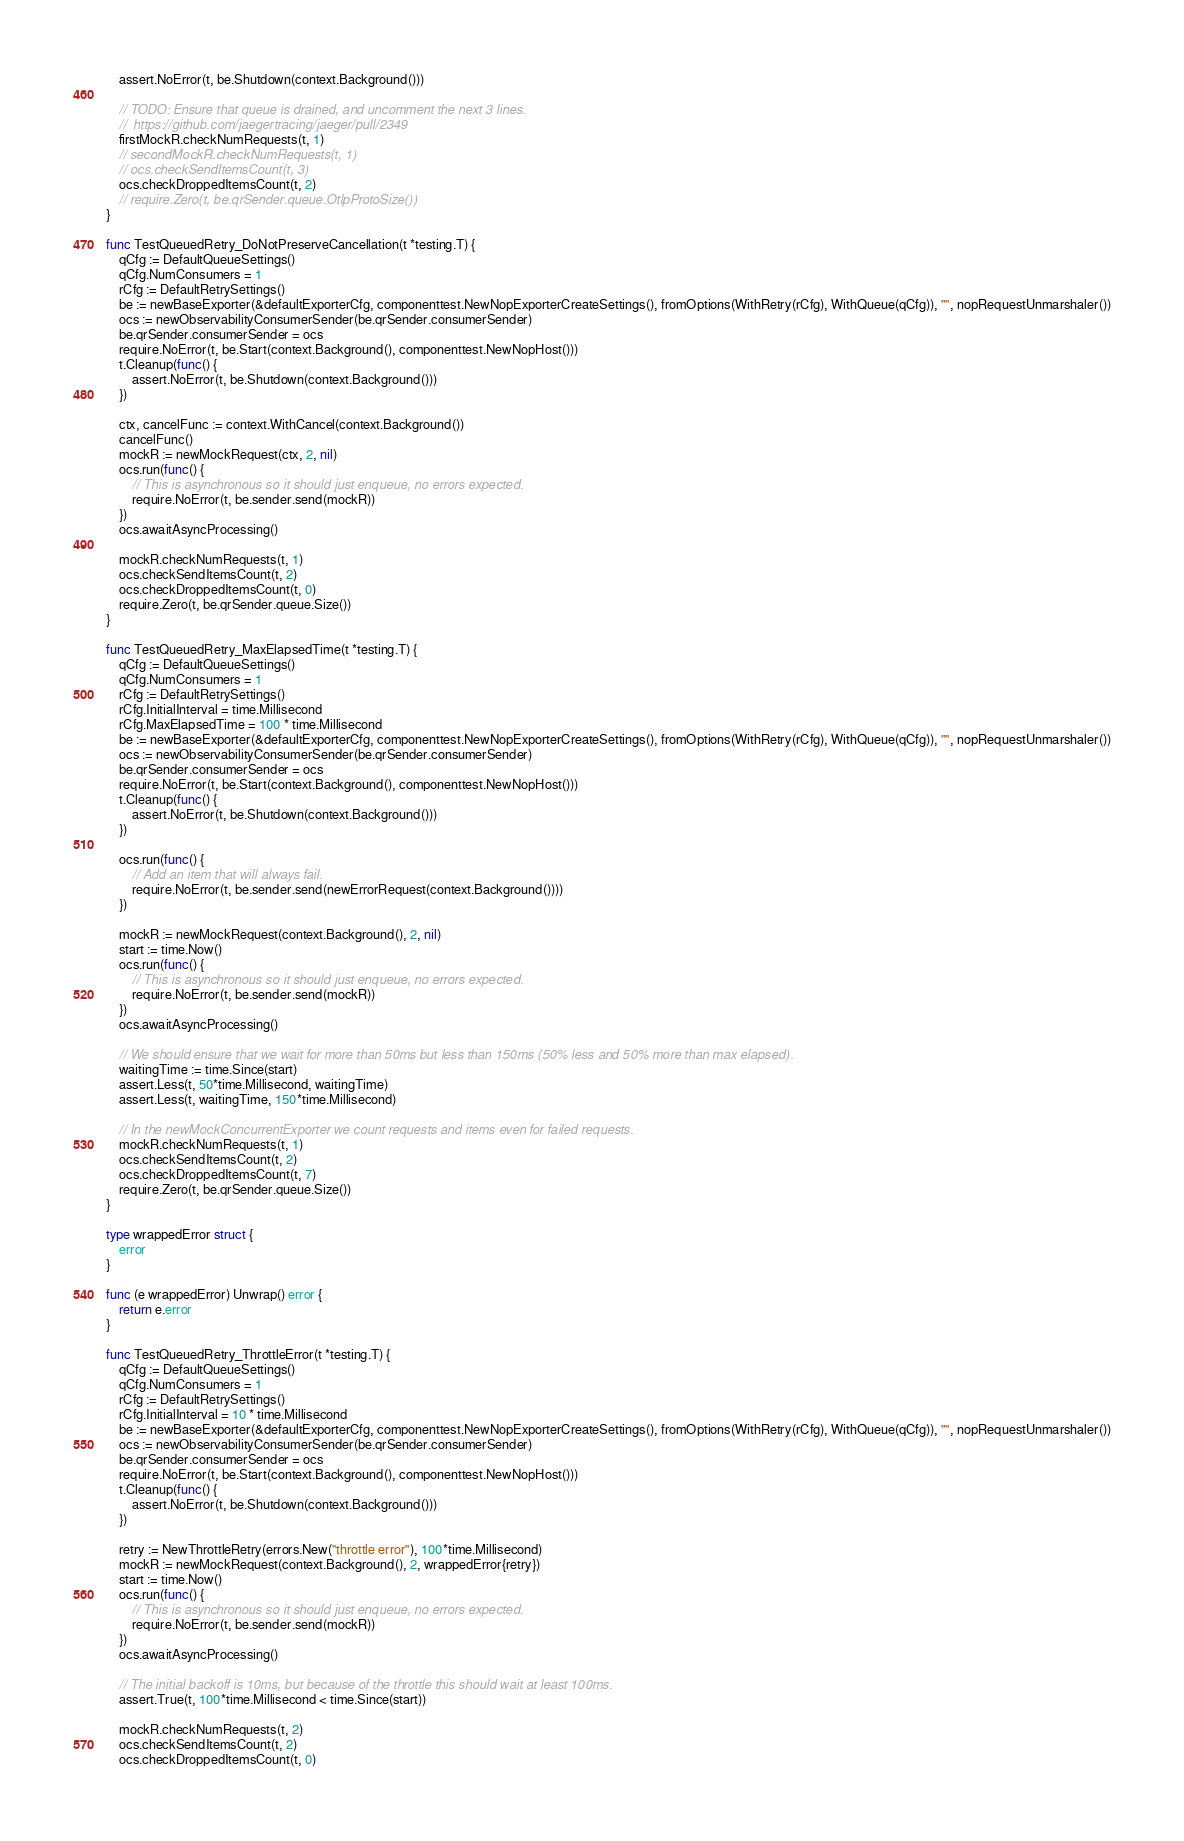Convert code to text. <code><loc_0><loc_0><loc_500><loc_500><_Go_>	assert.NoError(t, be.Shutdown(context.Background()))

	// TODO: Ensure that queue is drained, and uncomment the next 3 lines.
	//  https://github.com/jaegertracing/jaeger/pull/2349
	firstMockR.checkNumRequests(t, 1)
	// secondMockR.checkNumRequests(t, 1)
	// ocs.checkSendItemsCount(t, 3)
	ocs.checkDroppedItemsCount(t, 2)
	// require.Zero(t, be.qrSender.queue.OtlpProtoSize())
}

func TestQueuedRetry_DoNotPreserveCancellation(t *testing.T) {
	qCfg := DefaultQueueSettings()
	qCfg.NumConsumers = 1
	rCfg := DefaultRetrySettings()
	be := newBaseExporter(&defaultExporterCfg, componenttest.NewNopExporterCreateSettings(), fromOptions(WithRetry(rCfg), WithQueue(qCfg)), "", nopRequestUnmarshaler())
	ocs := newObservabilityConsumerSender(be.qrSender.consumerSender)
	be.qrSender.consumerSender = ocs
	require.NoError(t, be.Start(context.Background(), componenttest.NewNopHost()))
	t.Cleanup(func() {
		assert.NoError(t, be.Shutdown(context.Background()))
	})

	ctx, cancelFunc := context.WithCancel(context.Background())
	cancelFunc()
	mockR := newMockRequest(ctx, 2, nil)
	ocs.run(func() {
		// This is asynchronous so it should just enqueue, no errors expected.
		require.NoError(t, be.sender.send(mockR))
	})
	ocs.awaitAsyncProcessing()

	mockR.checkNumRequests(t, 1)
	ocs.checkSendItemsCount(t, 2)
	ocs.checkDroppedItemsCount(t, 0)
	require.Zero(t, be.qrSender.queue.Size())
}

func TestQueuedRetry_MaxElapsedTime(t *testing.T) {
	qCfg := DefaultQueueSettings()
	qCfg.NumConsumers = 1
	rCfg := DefaultRetrySettings()
	rCfg.InitialInterval = time.Millisecond
	rCfg.MaxElapsedTime = 100 * time.Millisecond
	be := newBaseExporter(&defaultExporterCfg, componenttest.NewNopExporterCreateSettings(), fromOptions(WithRetry(rCfg), WithQueue(qCfg)), "", nopRequestUnmarshaler())
	ocs := newObservabilityConsumerSender(be.qrSender.consumerSender)
	be.qrSender.consumerSender = ocs
	require.NoError(t, be.Start(context.Background(), componenttest.NewNopHost()))
	t.Cleanup(func() {
		assert.NoError(t, be.Shutdown(context.Background()))
	})

	ocs.run(func() {
		// Add an item that will always fail.
		require.NoError(t, be.sender.send(newErrorRequest(context.Background())))
	})

	mockR := newMockRequest(context.Background(), 2, nil)
	start := time.Now()
	ocs.run(func() {
		// This is asynchronous so it should just enqueue, no errors expected.
		require.NoError(t, be.sender.send(mockR))
	})
	ocs.awaitAsyncProcessing()

	// We should ensure that we wait for more than 50ms but less than 150ms (50% less and 50% more than max elapsed).
	waitingTime := time.Since(start)
	assert.Less(t, 50*time.Millisecond, waitingTime)
	assert.Less(t, waitingTime, 150*time.Millisecond)

	// In the newMockConcurrentExporter we count requests and items even for failed requests.
	mockR.checkNumRequests(t, 1)
	ocs.checkSendItemsCount(t, 2)
	ocs.checkDroppedItemsCount(t, 7)
	require.Zero(t, be.qrSender.queue.Size())
}

type wrappedError struct {
	error
}

func (e wrappedError) Unwrap() error {
	return e.error
}

func TestQueuedRetry_ThrottleError(t *testing.T) {
	qCfg := DefaultQueueSettings()
	qCfg.NumConsumers = 1
	rCfg := DefaultRetrySettings()
	rCfg.InitialInterval = 10 * time.Millisecond
	be := newBaseExporter(&defaultExporterCfg, componenttest.NewNopExporterCreateSettings(), fromOptions(WithRetry(rCfg), WithQueue(qCfg)), "", nopRequestUnmarshaler())
	ocs := newObservabilityConsumerSender(be.qrSender.consumerSender)
	be.qrSender.consumerSender = ocs
	require.NoError(t, be.Start(context.Background(), componenttest.NewNopHost()))
	t.Cleanup(func() {
		assert.NoError(t, be.Shutdown(context.Background()))
	})

	retry := NewThrottleRetry(errors.New("throttle error"), 100*time.Millisecond)
	mockR := newMockRequest(context.Background(), 2, wrappedError{retry})
	start := time.Now()
	ocs.run(func() {
		// This is asynchronous so it should just enqueue, no errors expected.
		require.NoError(t, be.sender.send(mockR))
	})
	ocs.awaitAsyncProcessing()

	// The initial backoff is 10ms, but because of the throttle this should wait at least 100ms.
	assert.True(t, 100*time.Millisecond < time.Since(start))

	mockR.checkNumRequests(t, 2)
	ocs.checkSendItemsCount(t, 2)
	ocs.checkDroppedItemsCount(t, 0)</code> 